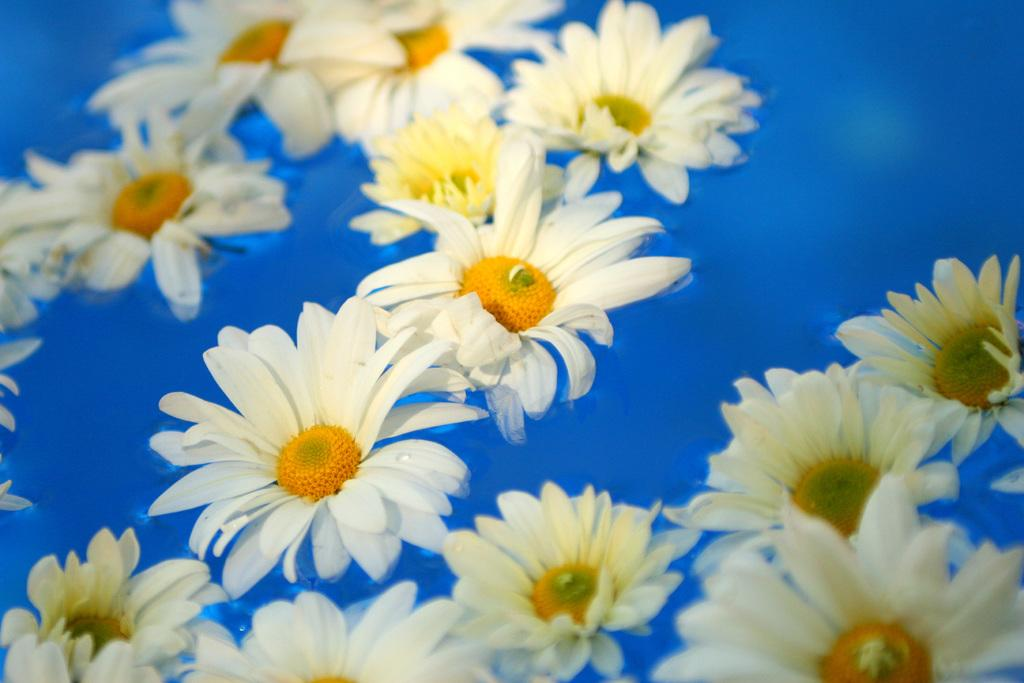What type of plants can be seen in the image? There are flowers in the image. What is visible at the bottom of the image? There is water visible at the bottom of the image. What parts of the flowers are present in the image? Petals of the flowers are present in the image. How many rings are visible on the fingers of the person in the image? There is no person present in the image, so it is not possible to determine the number of rings visible on their fingers. 